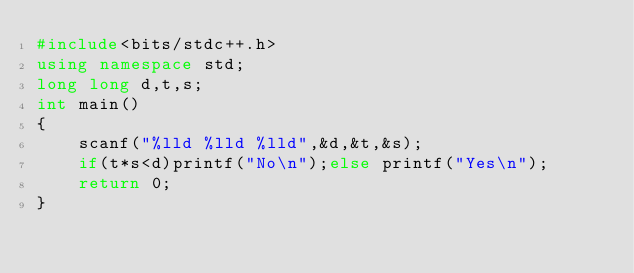Convert code to text. <code><loc_0><loc_0><loc_500><loc_500><_C++_>#include<bits/stdc++.h>
using namespace std;
long long d,t,s;
int main()
{
    scanf("%lld %lld %lld",&d,&t,&s);
    if(t*s<d)printf("No\n");else printf("Yes\n");
    return 0;
}
</code> 